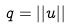<formula> <loc_0><loc_0><loc_500><loc_500>q = | | u | |</formula> 